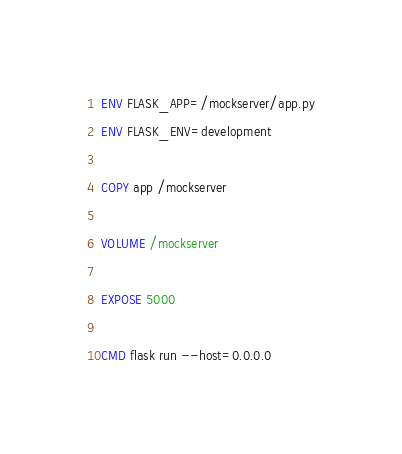Convert code to text. <code><loc_0><loc_0><loc_500><loc_500><_Dockerfile_>
ENV FLASK_APP=/mockserver/app.py
ENV FLASK_ENV=development

COPY app /mockserver

VOLUME /mockserver

EXPOSE 5000

CMD flask run --host=0.0.0.0

</code> 